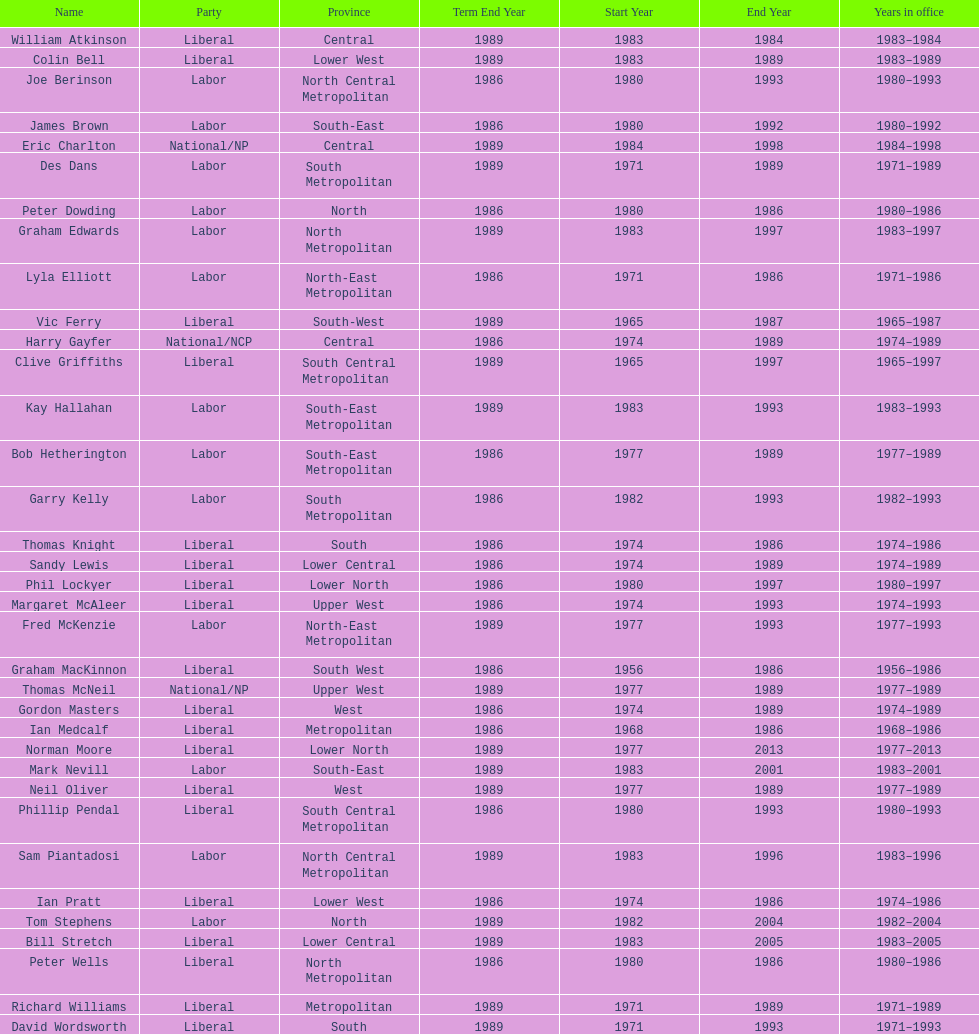What is the total number of members whose term expires in 1989? 9. 